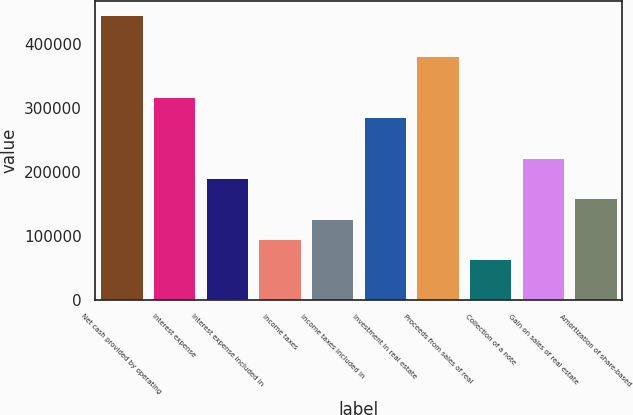<chart> <loc_0><loc_0><loc_500><loc_500><bar_chart><fcel>Net cash provided by operating<fcel>Interest expense<fcel>Interest expense included in<fcel>Income taxes<fcel>Income taxes included in<fcel>Investment in real estate<fcel>Proceeds from sales of real<fcel>Collection of a note<fcel>Gain on sales of real estate<fcel>Amortization of share-based<nl><fcel>445435<fcel>318169<fcel>190903<fcel>95453.6<fcel>127270<fcel>286353<fcel>381802<fcel>63637.1<fcel>222720<fcel>159087<nl></chart> 